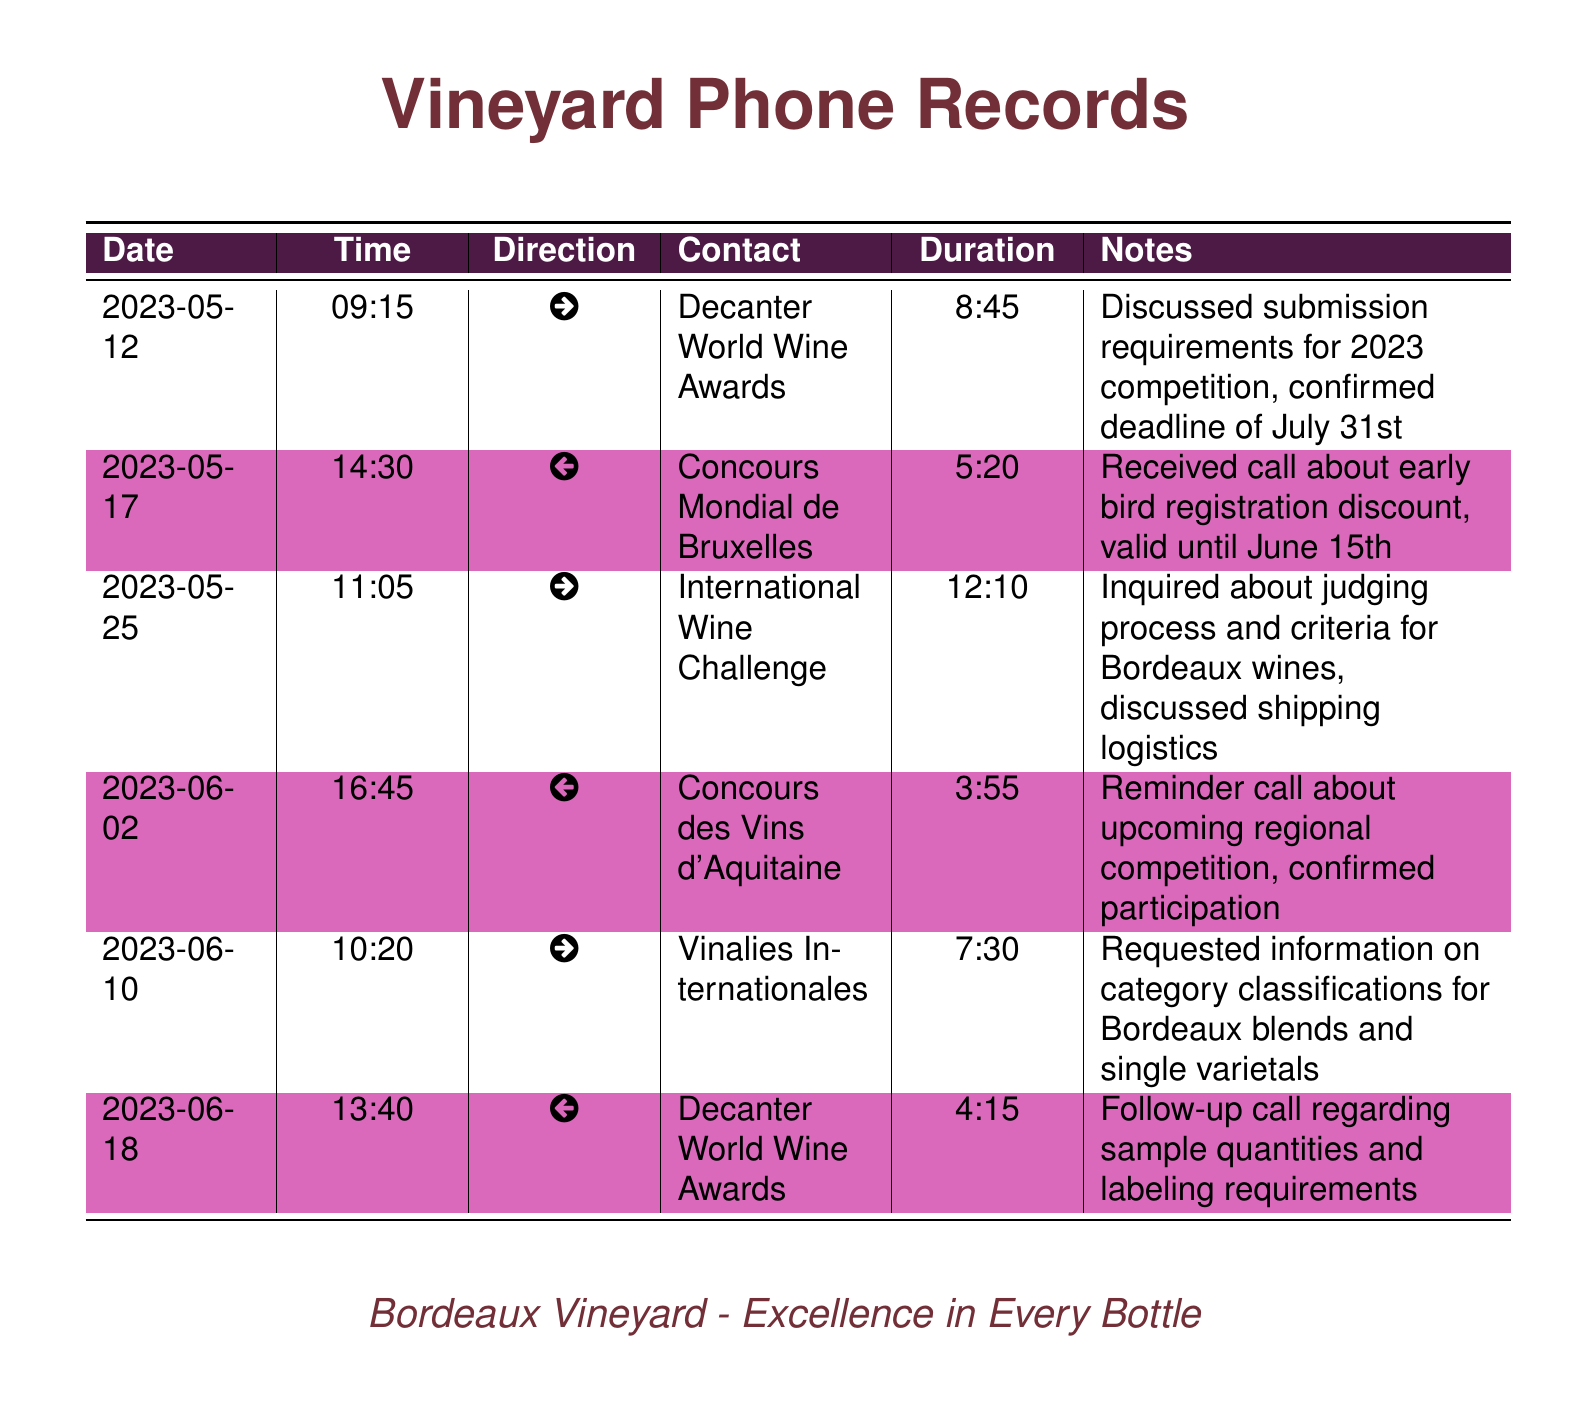What is the submission deadline for the Decanter World Wine Awards? The submission deadline is mentioned specifically in the notes section of the call on May 12, which states it is July 31st.
Answer: July 31st What was discussed during the call with the International Wine Challenge? The notes indicate that the discussion involved inquiries about judging process, criteria for Bordeaux wines, and shipping logistics.
Answer: Judging process and shipping logistics How long was the call with Concours Mondial de Bruxelles? The duration of the call is explicitly listed as 5 minutes and 20 seconds.
Answer: 5:20 When did the vineyard confirm participation in the regional competition? The confirmation of participation is noted in the call with Concours des Vins d'Aquitaine on June 2.
Answer: June 2 What type of discount was mentioned in the call with Concours Mondial de Bruxelles? The call notes reference an early bird registration discount valid until a certain date.
Answer: Early bird registration discount Who did you speak with on June 10 regarding category classifications? The document specifies that the call was made to Vinalies Internationales related to category classifications.
Answer: Vinalies Internationales What was the total duration of the call with Decanter World Wine Awards on June 18? The duration is clearly stated in the notes, indicating it lasted 4 minutes and 15 seconds.
Answer: 4:15 What type of wines were inquired about during the call with International Wine Challenge? The inquiry specified the focus on Bordeaux wines in the context of judging process and criteria.
Answer: Bordeaux wines 